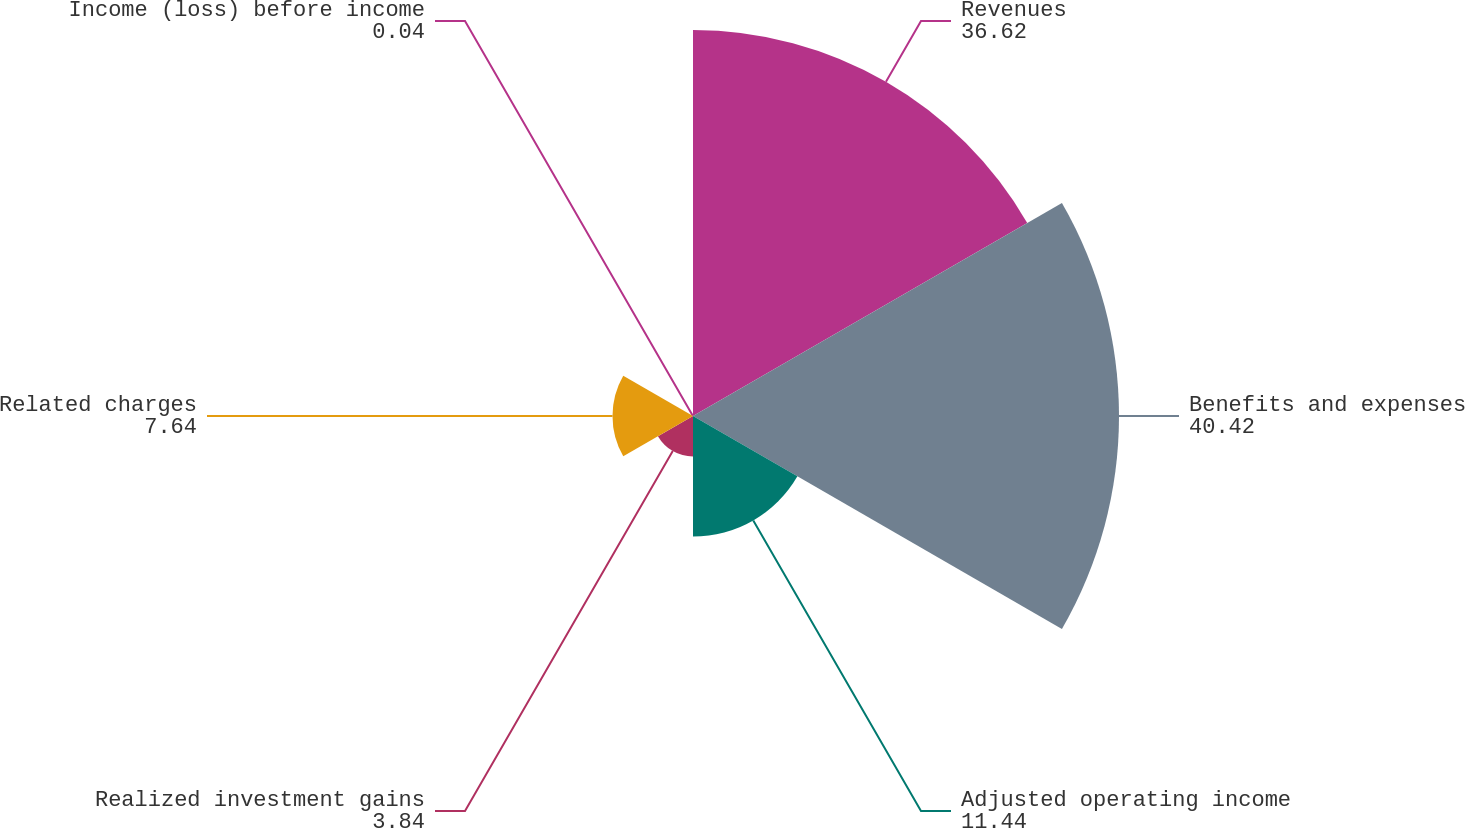<chart> <loc_0><loc_0><loc_500><loc_500><pie_chart><fcel>Revenues<fcel>Benefits and expenses<fcel>Adjusted operating income<fcel>Realized investment gains<fcel>Related charges<fcel>Income (loss) before income<nl><fcel>36.62%<fcel>40.42%<fcel>11.44%<fcel>3.84%<fcel>7.64%<fcel>0.04%<nl></chart> 